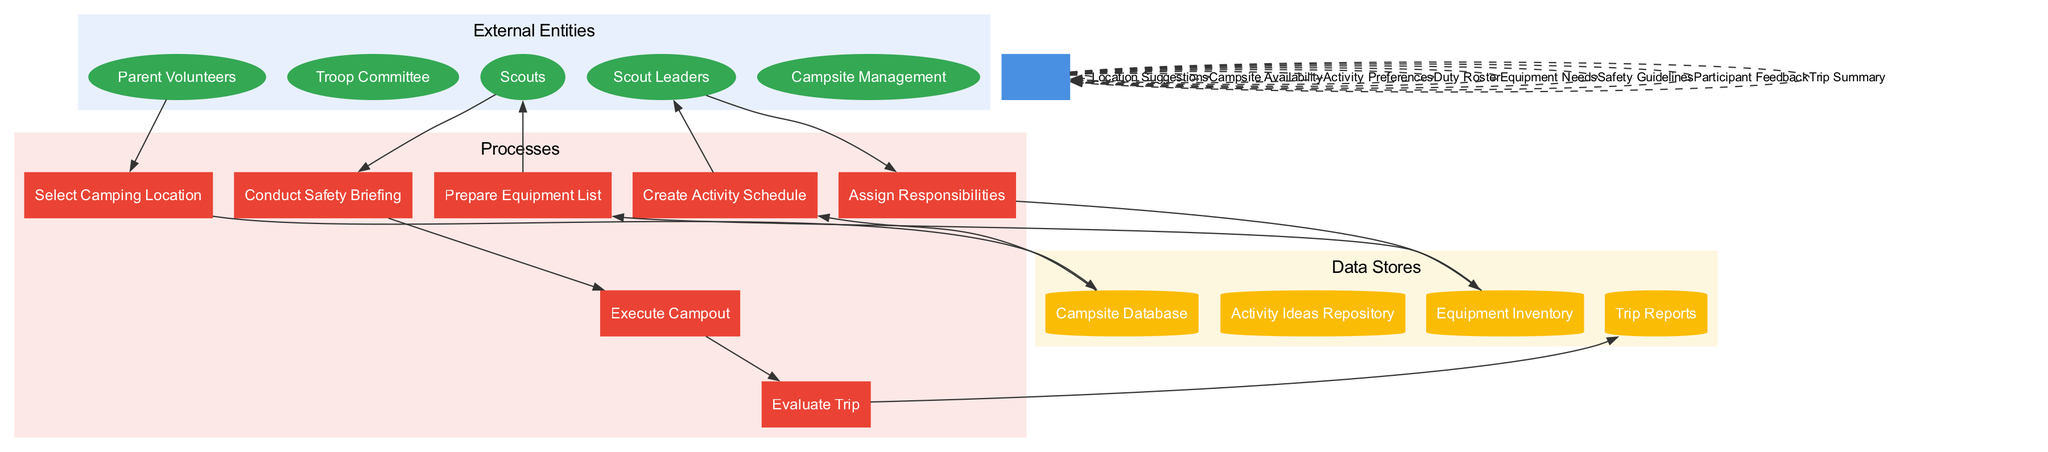What are the external entities in the diagram? The external entities are listed at the top section of the diagram and include Parent Volunteers, Troop Committee, Scout Leaders, Scouts, and Campsite Management. Each entity plays a role in the overall campout planning process.
Answer: Parent Volunteers, Troop Committee, Scout Leaders, Scouts, Campsite Management How many processes are there in the diagram? By counting the processes listed in the diagram, there are a total of seven distinct processes involved in the campout planning process, which are crucial for organizing the campout effectively.
Answer: 7 Which process does the 'Duty Roster' data flow connect to? The 'Duty Roster' data flow connects the process of Assign Responsibilities to the Troop Committee, indicating that they provide input regarding who will handle various roles during the campout.
Answer: Assign Responsibilities What do the data stores contain? The data stores contain specific categories of information relevant to the campout, including Campsite Database, Activity Ideas Repository, Equipment Inventory, and Trip Reports. These repositories are crucial for managing resources and planning activities.
Answer: Campsite Database, Activity Ideas Repository, Equipment Inventory, Trip Reports What is the order of processes from location selection to evaluation? The order of processes begins with Select Camping Location, then progresses sequentially through Create Activity Schedule, Assign Responsibilities, Prepare Equipment List, Conduct Safety Briefing, Execute Campout, and finally concludes with Evaluate Trip. This sequence ensures a comprehensive approach to campout planning.
Answer: Select Camping Location, Create Activity Schedule, Assign Responsibilities, Prepare Equipment List, Conduct Safety Briefing, Execute Campout, Evaluate Trip How does the Scouts' participation flow to the Conduct Safety Briefing process? The Scouts provide input in the form of Participation Feedback, which is essential in ensuring that they are informed and prepared for safety measures during the campout; this feedback connects Scouts to the Conduct Safety Briefing process.
Answer: Participation Feedback Which external entity provides 'Location Suggestions'? The external entity providing 'Location Suggestions' to the Select Camping Location process is the Parent Volunteers. Their input is valuable in deciding suitable camping sites based on their experiences or preferences.
Answer: Parent Volunteers 